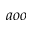Convert formula to latex. <formula><loc_0><loc_0><loc_500><loc_500>a o o</formula> 